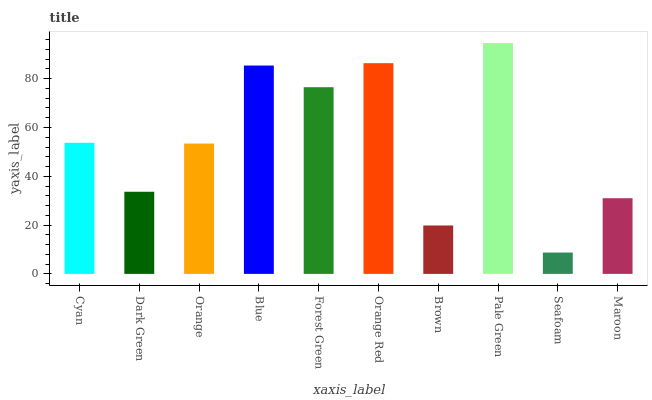Is Dark Green the minimum?
Answer yes or no. No. Is Dark Green the maximum?
Answer yes or no. No. Is Cyan greater than Dark Green?
Answer yes or no. Yes. Is Dark Green less than Cyan?
Answer yes or no. Yes. Is Dark Green greater than Cyan?
Answer yes or no. No. Is Cyan less than Dark Green?
Answer yes or no. No. Is Cyan the high median?
Answer yes or no. Yes. Is Orange the low median?
Answer yes or no. Yes. Is Dark Green the high median?
Answer yes or no. No. Is Maroon the low median?
Answer yes or no. No. 